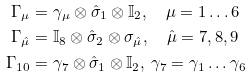<formula> <loc_0><loc_0><loc_500><loc_500>\Gamma _ { \mu } & = \gamma _ { \mu } \otimes \hat { \sigma } _ { 1 } \otimes \mathbb { I } _ { 2 } , \quad \mu = 1 \dots 6 \\ \Gamma _ { \hat { \mu } } & = \mathbb { I } _ { 8 } \otimes \hat { \sigma } _ { 2 } \otimes \sigma _ { \hat { \mu } } , \quad \hat { \mu } = 7 , 8 , 9 \\ \Gamma _ { 1 0 } & = \gamma _ { 7 } \otimes \hat { \sigma } _ { 1 } \otimes \mathbb { I } _ { 2 } , \, \gamma _ { 7 } = \gamma _ { 1 } \dots \gamma _ { 6 }</formula> 